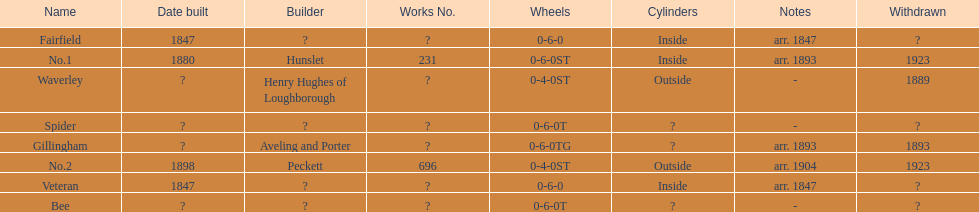What is the total number of names on the chart? 8. 